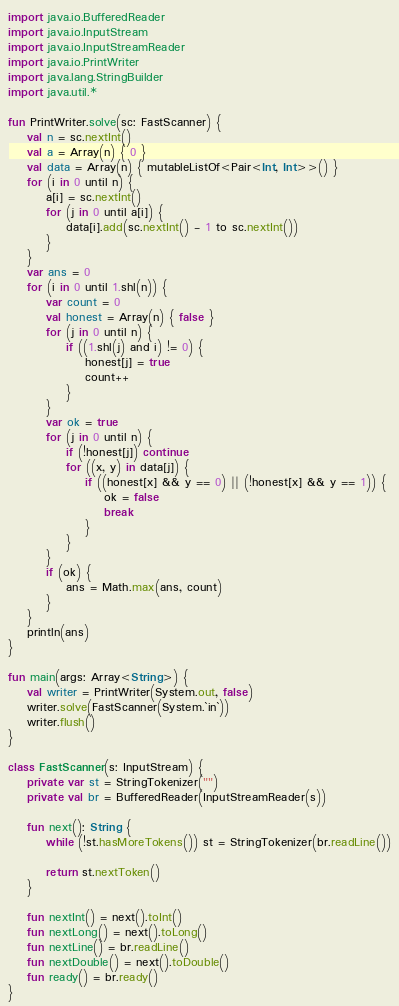<code> <loc_0><loc_0><loc_500><loc_500><_Kotlin_>import java.io.BufferedReader
import java.io.InputStream
import java.io.InputStreamReader
import java.io.PrintWriter
import java.lang.StringBuilder
import java.util.*

fun PrintWriter.solve(sc: FastScanner) {
    val n = sc.nextInt()
    val a = Array(n) { 0 }
    val data = Array(n) { mutableListOf<Pair<Int, Int>>() }
    for (i in 0 until n) {
        a[i] = sc.nextInt()
        for (j in 0 until a[i]) {
            data[i].add(sc.nextInt() - 1 to sc.nextInt())
        }
    }
    var ans = 0
    for (i in 0 until 1.shl(n)) {
        var count = 0
        val honest = Array(n) { false }
        for (j in 0 until n) {
            if ((1.shl(j) and i) != 0) {
                honest[j] = true
                count++
            }
        }
        var ok = true
        for (j in 0 until n) {
            if (!honest[j]) continue
            for ((x, y) in data[j]) {
                if ((honest[x] && y == 0) || (!honest[x] && y == 1)) {
                    ok = false
                    break
                }
            }
        }
        if (ok) {
            ans = Math.max(ans, count)
        }
    }
    println(ans)
}

fun main(args: Array<String>) {
    val writer = PrintWriter(System.out, false)
    writer.solve(FastScanner(System.`in`))
    writer.flush()
}

class FastScanner(s: InputStream) {
    private var st = StringTokenizer("")
    private val br = BufferedReader(InputStreamReader(s))

    fun next(): String {
        while (!st.hasMoreTokens()) st = StringTokenizer(br.readLine())

        return st.nextToken()
    }

    fun nextInt() = next().toInt()
    fun nextLong() = next().toLong()
    fun nextLine() = br.readLine()
    fun nextDouble() = next().toDouble()
    fun ready() = br.ready()
}
</code> 